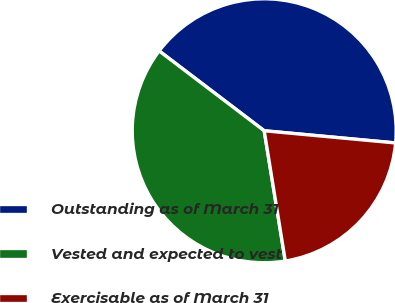Convert chart. <chart><loc_0><loc_0><loc_500><loc_500><pie_chart><fcel>Outstanding as of March 31<fcel>Vested and expected to vest<fcel>Exercisable as of March 31<nl><fcel>41.13%<fcel>37.9%<fcel>20.97%<nl></chart> 